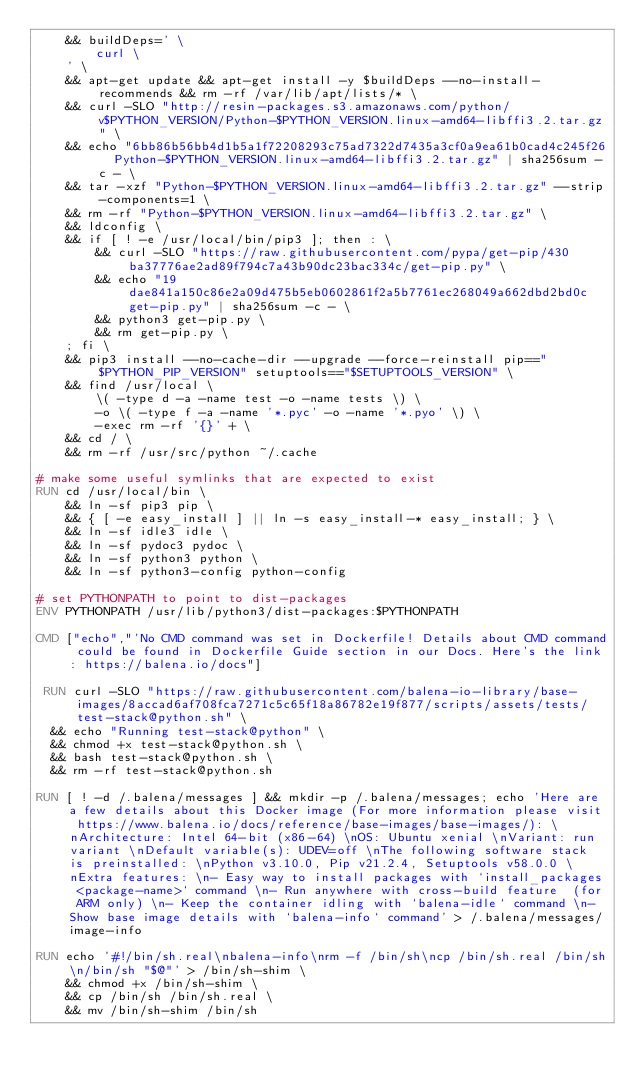<code> <loc_0><loc_0><loc_500><loc_500><_Dockerfile_>	&& buildDeps=' \
		curl \
	' \
	&& apt-get update && apt-get install -y $buildDeps --no-install-recommends && rm -rf /var/lib/apt/lists/* \
	&& curl -SLO "http://resin-packages.s3.amazonaws.com/python/v$PYTHON_VERSION/Python-$PYTHON_VERSION.linux-amd64-libffi3.2.tar.gz" \
	&& echo "6bb86b56bb4d1b5a1f72208293c75ad7322d7435a3cf0a9ea61b0cad4c245f26  Python-$PYTHON_VERSION.linux-amd64-libffi3.2.tar.gz" | sha256sum -c - \
	&& tar -xzf "Python-$PYTHON_VERSION.linux-amd64-libffi3.2.tar.gz" --strip-components=1 \
	&& rm -rf "Python-$PYTHON_VERSION.linux-amd64-libffi3.2.tar.gz" \
	&& ldconfig \
	&& if [ ! -e /usr/local/bin/pip3 ]; then : \
		&& curl -SLO "https://raw.githubusercontent.com/pypa/get-pip/430ba37776ae2ad89f794c7a43b90dc23bac334c/get-pip.py" \
		&& echo "19dae841a150c86e2a09d475b5eb0602861f2a5b7761ec268049a662dbd2bd0c  get-pip.py" | sha256sum -c - \
		&& python3 get-pip.py \
		&& rm get-pip.py \
	; fi \
	&& pip3 install --no-cache-dir --upgrade --force-reinstall pip=="$PYTHON_PIP_VERSION" setuptools=="$SETUPTOOLS_VERSION" \
	&& find /usr/local \
		\( -type d -a -name test -o -name tests \) \
		-o \( -type f -a -name '*.pyc' -o -name '*.pyo' \) \
		-exec rm -rf '{}' + \
	&& cd / \
	&& rm -rf /usr/src/python ~/.cache

# make some useful symlinks that are expected to exist
RUN cd /usr/local/bin \
	&& ln -sf pip3 pip \
	&& { [ -e easy_install ] || ln -s easy_install-* easy_install; } \
	&& ln -sf idle3 idle \
	&& ln -sf pydoc3 pydoc \
	&& ln -sf python3 python \
	&& ln -sf python3-config python-config

# set PYTHONPATH to point to dist-packages
ENV PYTHONPATH /usr/lib/python3/dist-packages:$PYTHONPATH

CMD ["echo","'No CMD command was set in Dockerfile! Details about CMD command could be found in Dockerfile Guide section in our Docs. Here's the link: https://balena.io/docs"]

 RUN curl -SLO "https://raw.githubusercontent.com/balena-io-library/base-images/8accad6af708fca7271c5c65f18a86782e19f877/scripts/assets/tests/test-stack@python.sh" \
  && echo "Running test-stack@python" \
  && chmod +x test-stack@python.sh \
  && bash test-stack@python.sh \
  && rm -rf test-stack@python.sh 

RUN [ ! -d /.balena/messages ] && mkdir -p /.balena/messages; echo 'Here are a few details about this Docker image (For more information please visit https://www.balena.io/docs/reference/base-images/base-images/): \nArchitecture: Intel 64-bit (x86-64) \nOS: Ubuntu xenial \nVariant: run variant \nDefault variable(s): UDEV=off \nThe following software stack is preinstalled: \nPython v3.10.0, Pip v21.2.4, Setuptools v58.0.0 \nExtra features: \n- Easy way to install packages with `install_packages <package-name>` command \n- Run anywhere with cross-build feature  (for ARM only) \n- Keep the container idling with `balena-idle` command \n- Show base image details with `balena-info` command' > /.balena/messages/image-info

RUN echo '#!/bin/sh.real\nbalena-info\nrm -f /bin/sh\ncp /bin/sh.real /bin/sh\n/bin/sh "$@"' > /bin/sh-shim \
	&& chmod +x /bin/sh-shim \
	&& cp /bin/sh /bin/sh.real \
	&& mv /bin/sh-shim /bin/sh</code> 